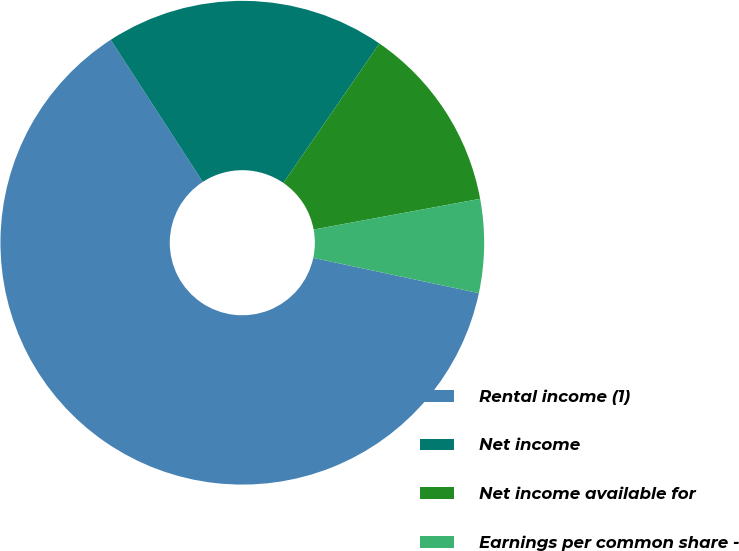Convert chart. <chart><loc_0><loc_0><loc_500><loc_500><pie_chart><fcel>Rental income (1)<fcel>Net income<fcel>Net income available for<fcel>Earnings per common share -<nl><fcel>62.5%<fcel>18.75%<fcel>12.5%<fcel>6.25%<nl></chart> 